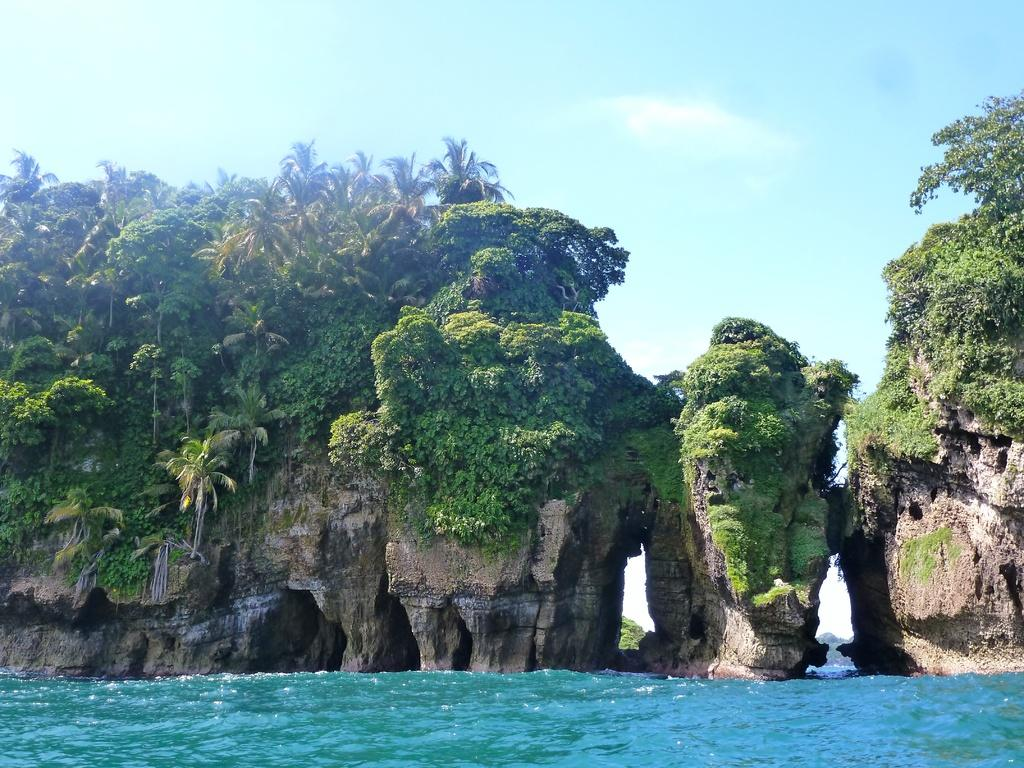What type of natural elements can be seen in the image? There are rocks and trees visible in the image. What can be seen at the bottom of the image? There is water visible at the bottom of the image. What is visible in the background of the image? The sky is visible in the background of the image. What rule is being enforced by the rocks in the image? There is no rule being enforced by the rocks in the image; they are simply natural elements. 